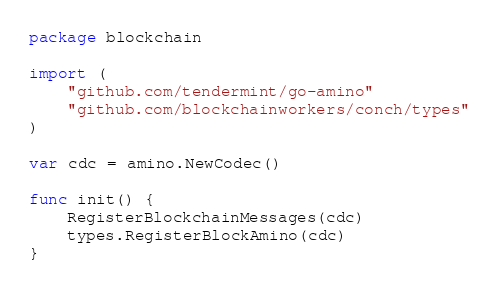Convert code to text. <code><loc_0><loc_0><loc_500><loc_500><_Go_>package blockchain

import (
	"github.com/tendermint/go-amino"
	"github.com/blockchainworkers/conch/types"
)

var cdc = amino.NewCodec()

func init() {
	RegisterBlockchainMessages(cdc)
	types.RegisterBlockAmino(cdc)
}
</code> 